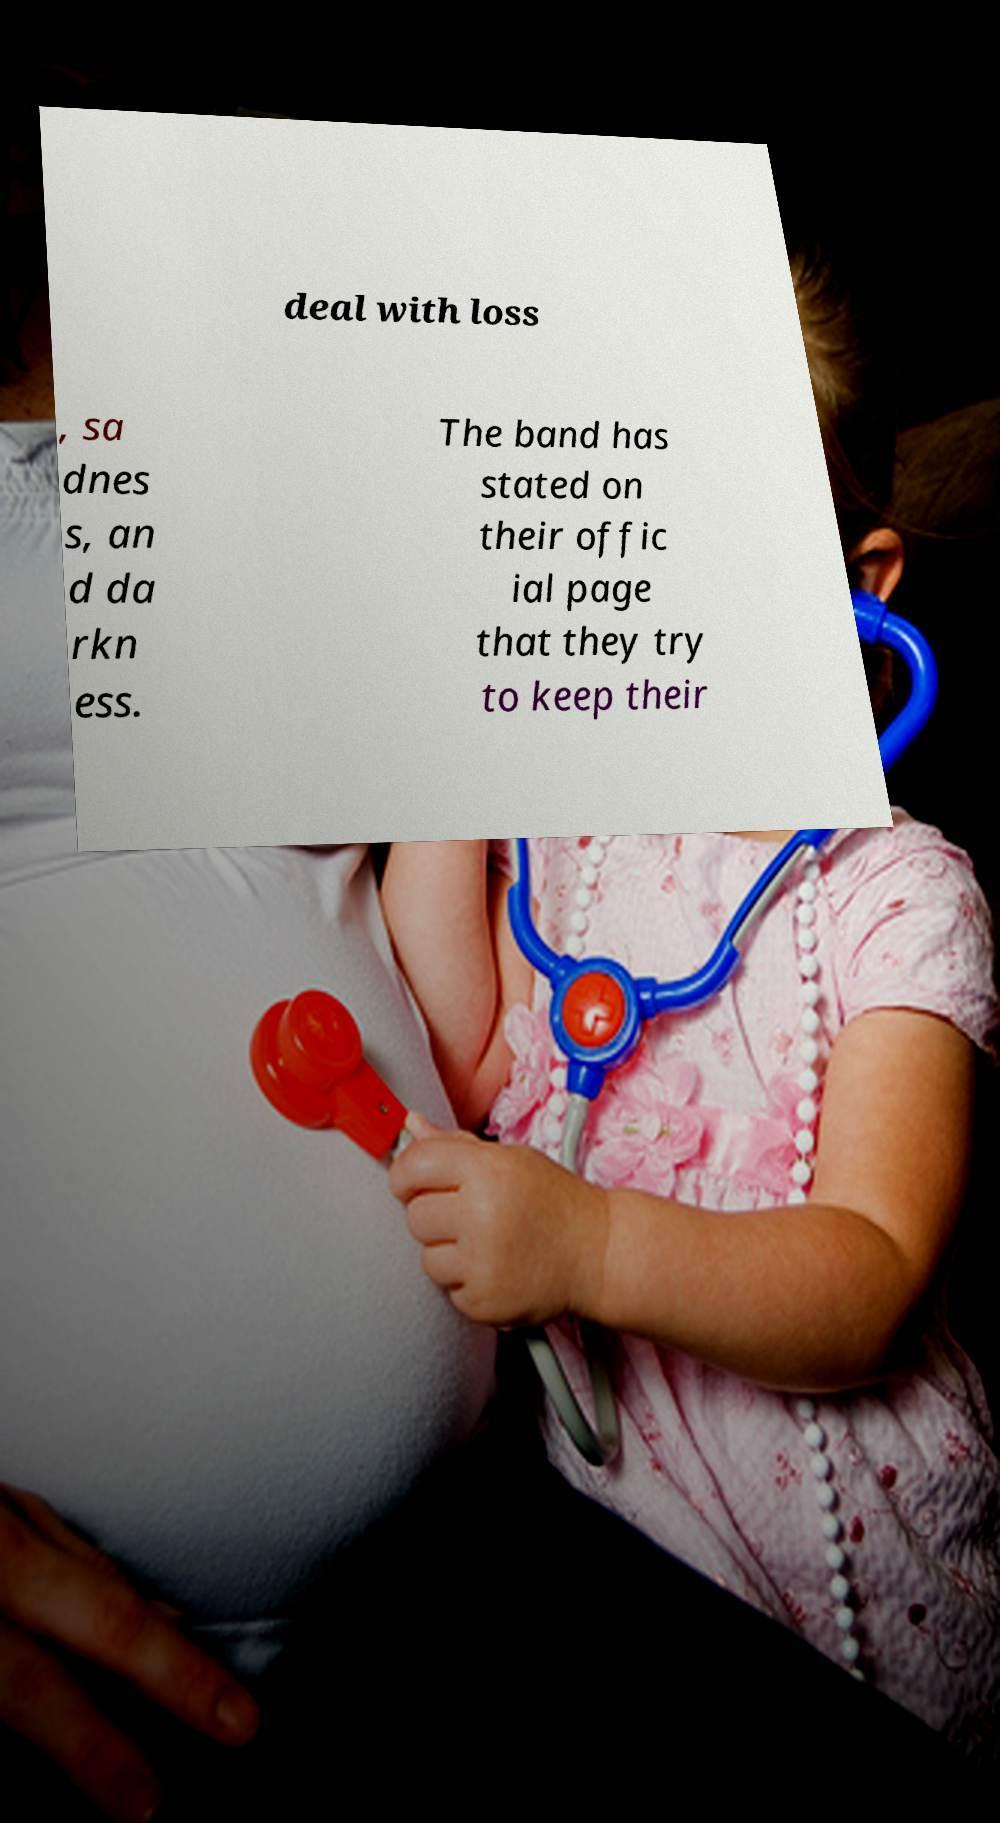Could you extract and type out the text from this image? deal with loss , sa dnes s, an d da rkn ess. The band has stated on their offic ial page that they try to keep their 